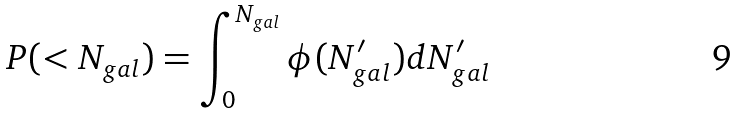Convert formula to latex. <formula><loc_0><loc_0><loc_500><loc_500>P ( < N _ { g a l } ) = \int _ { 0 } ^ { N _ { g a l } } \phi ( N ^ { \prime } _ { g a l } ) d N ^ { \prime } _ { g a l }</formula> 